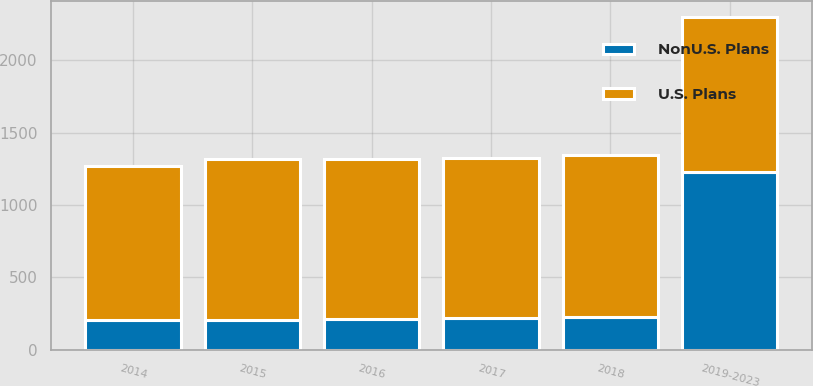Convert chart to OTSL. <chart><loc_0><loc_0><loc_500><loc_500><stacked_bar_chart><ecel><fcel>2014<fcel>2015<fcel>2016<fcel>2017<fcel>2018<fcel>2019-2023<nl><fcel>U.S. Plans<fcel>1068<fcel>1111<fcel>1106<fcel>1105<fcel>1118<fcel>1068<nl><fcel>NonU.S. Plans<fcel>202<fcel>208<fcel>213<fcel>219<fcel>226<fcel>1228<nl></chart> 